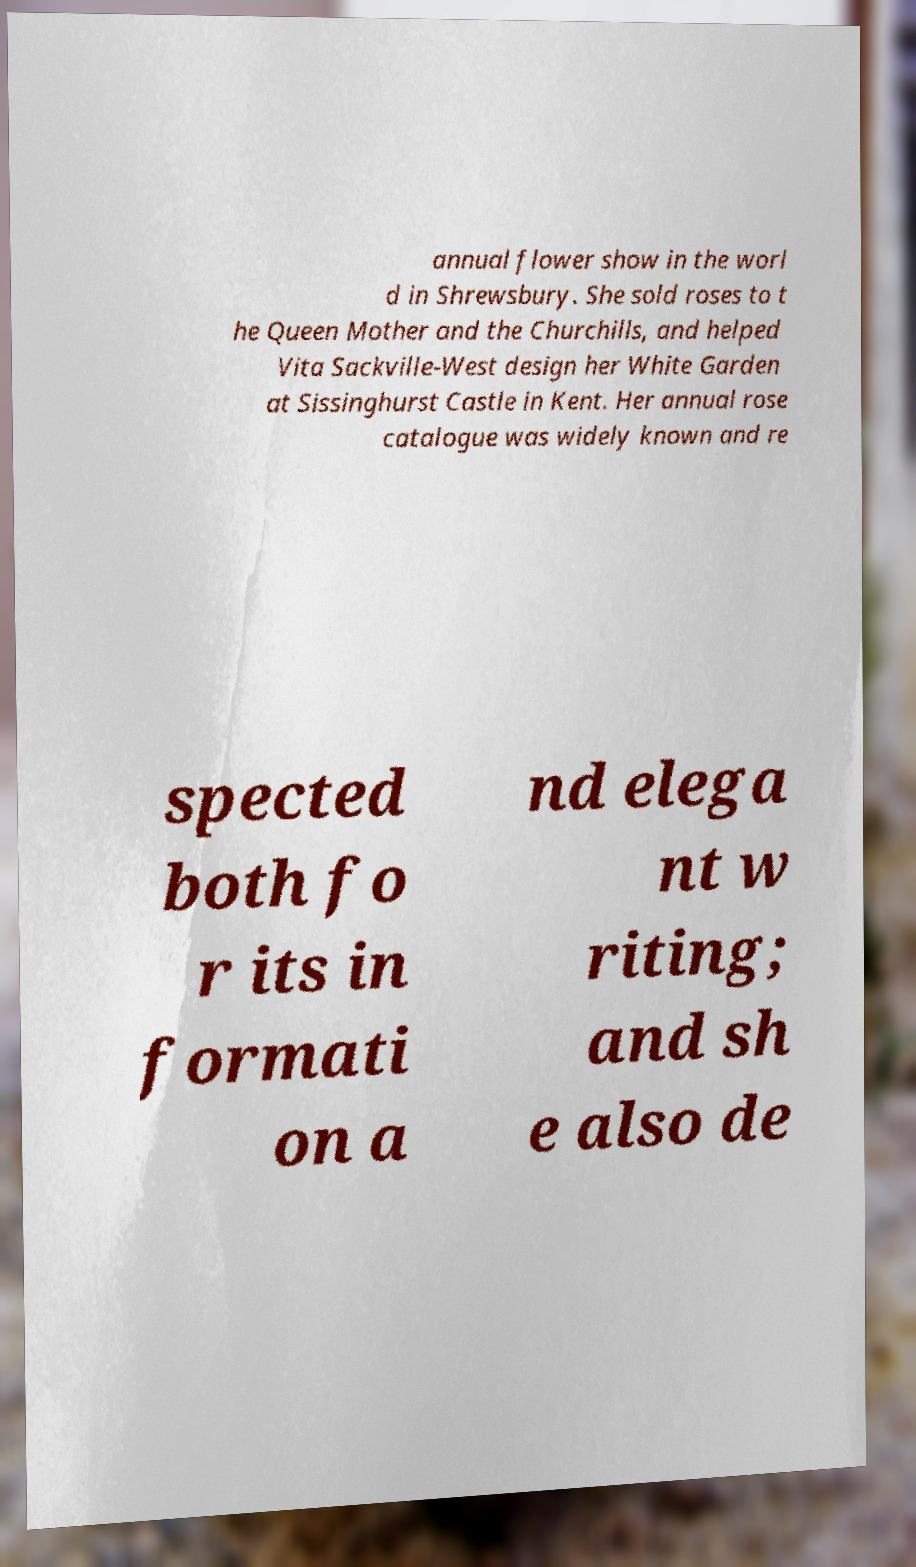Please identify and transcribe the text found in this image. annual flower show in the worl d in Shrewsbury. She sold roses to t he Queen Mother and the Churchills, and helped Vita Sackville-West design her White Garden at Sissinghurst Castle in Kent. Her annual rose catalogue was widely known and re spected both fo r its in formati on a nd elega nt w riting; and sh e also de 